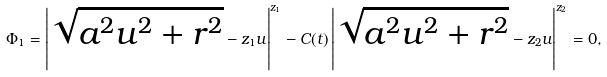<formula> <loc_0><loc_0><loc_500><loc_500>\Phi _ { 1 } = \left | \sqrt { a ^ { 2 } u ^ { 2 } + r ^ { 2 } } - z _ { 1 } u \right | ^ { z _ { 1 } } - C ( t ) \left | \sqrt { a ^ { 2 } u ^ { 2 } + r ^ { 2 } } - z _ { 2 } u \right | ^ { z _ { 2 } } = 0 ,</formula> 